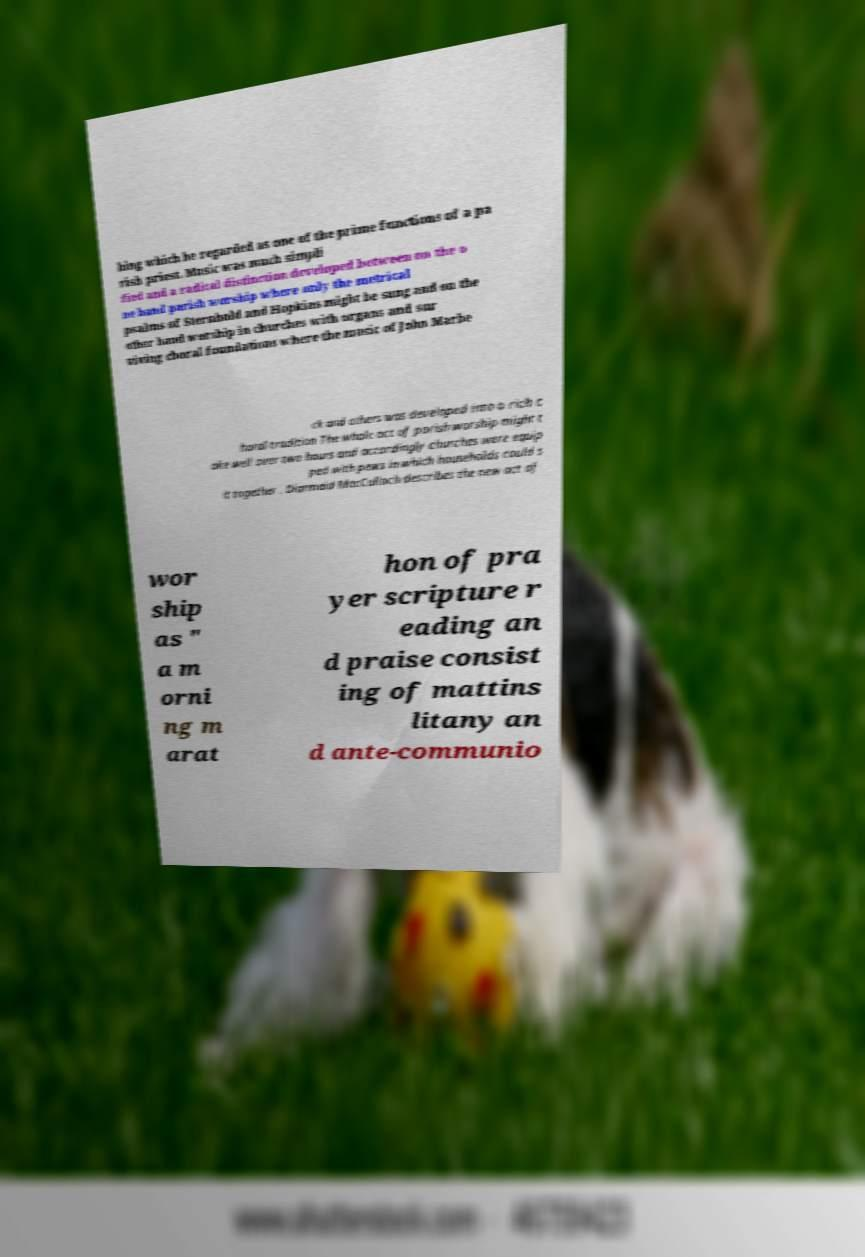Can you read and provide the text displayed in the image?This photo seems to have some interesting text. Can you extract and type it out for me? hing which he regarded as one of the prime functions of a pa rish priest. Music was much simpli fied and a radical distinction developed between on the o ne hand parish worship where only the metrical psalms of Sternhold and Hopkins might be sung and on the other hand worship in churches with organs and sur viving choral foundations where the music of John Marbe ck and others was developed into a rich c horal tradition The whole act of parish worship might t ake well over two hours and accordingly churches were equip ped with pews in which households could s it together . Diarmaid MacCulloch describes the new act of wor ship as " a m orni ng m arat hon of pra yer scripture r eading an d praise consist ing of mattins litany an d ante-communio 